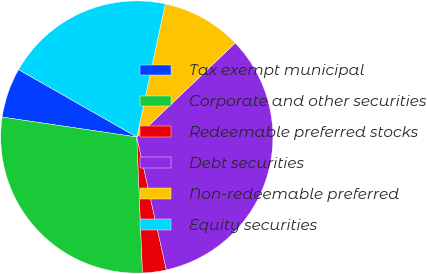Convert chart to OTSL. <chart><loc_0><loc_0><loc_500><loc_500><pie_chart><fcel>Tax exempt municipal<fcel>Corporate and other securities<fcel>Redeemable preferred stocks<fcel>Debt securities<fcel>Non-redeemable preferred<fcel>Equity securities<nl><fcel>5.91%<fcel>28.0%<fcel>2.82%<fcel>33.66%<fcel>9.51%<fcel>20.1%<nl></chart> 